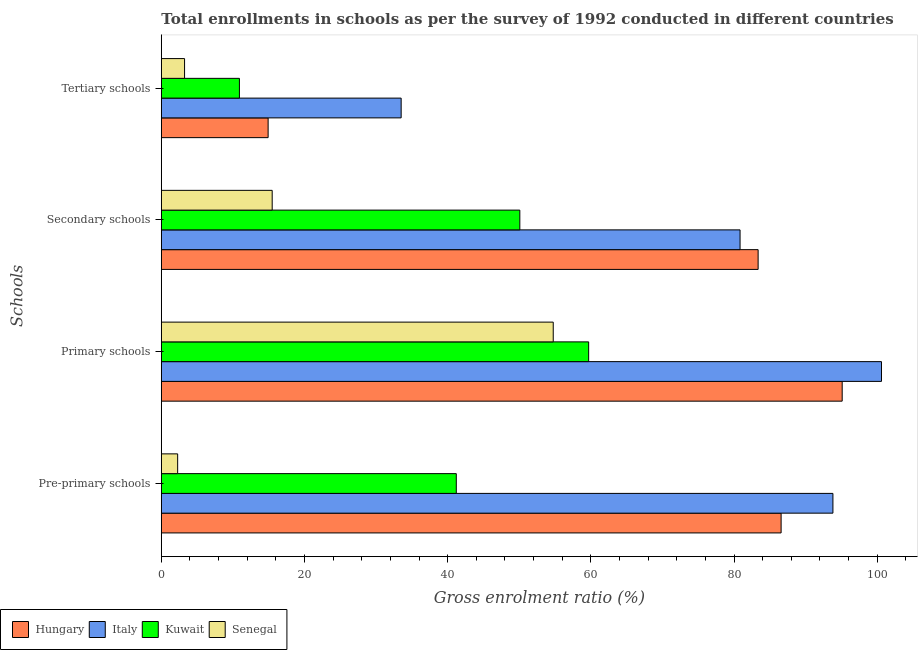Are the number of bars per tick equal to the number of legend labels?
Ensure brevity in your answer.  Yes. What is the label of the 4th group of bars from the top?
Make the answer very short. Pre-primary schools. What is the gross enrolment ratio in secondary schools in Senegal?
Give a very brief answer. 15.49. Across all countries, what is the maximum gross enrolment ratio in secondary schools?
Provide a succinct answer. 83.37. Across all countries, what is the minimum gross enrolment ratio in secondary schools?
Offer a terse response. 15.49. In which country was the gross enrolment ratio in pre-primary schools minimum?
Make the answer very short. Senegal. What is the total gross enrolment ratio in secondary schools in the graph?
Your response must be concise. 229.77. What is the difference between the gross enrolment ratio in tertiary schools in Kuwait and that in Hungary?
Offer a terse response. -4.01. What is the difference between the gross enrolment ratio in secondary schools in Senegal and the gross enrolment ratio in tertiary schools in Hungary?
Your answer should be compact. 0.57. What is the average gross enrolment ratio in primary schools per country?
Your answer should be compact. 77.54. What is the difference between the gross enrolment ratio in primary schools and gross enrolment ratio in secondary schools in Kuwait?
Give a very brief answer. 9.61. In how many countries, is the gross enrolment ratio in pre-primary schools greater than 4 %?
Ensure brevity in your answer.  3. What is the ratio of the gross enrolment ratio in primary schools in Senegal to that in Italy?
Your answer should be very brief. 0.54. Is the difference between the gross enrolment ratio in primary schools in Hungary and Kuwait greater than the difference between the gross enrolment ratio in pre-primary schools in Hungary and Kuwait?
Keep it short and to the point. No. What is the difference between the highest and the second highest gross enrolment ratio in secondary schools?
Offer a very short reply. 2.52. What is the difference between the highest and the lowest gross enrolment ratio in tertiary schools?
Keep it short and to the point. 30.25. Is the sum of the gross enrolment ratio in primary schools in Kuwait and Senegal greater than the maximum gross enrolment ratio in pre-primary schools across all countries?
Make the answer very short. Yes. What does the 4th bar from the top in Tertiary schools represents?
Your response must be concise. Hungary. What does the 4th bar from the bottom in Secondary schools represents?
Provide a succinct answer. Senegal. Is it the case that in every country, the sum of the gross enrolment ratio in pre-primary schools and gross enrolment ratio in primary schools is greater than the gross enrolment ratio in secondary schools?
Provide a short and direct response. Yes. How many bars are there?
Keep it short and to the point. 16. Are the values on the major ticks of X-axis written in scientific E-notation?
Your response must be concise. No. Does the graph contain any zero values?
Offer a terse response. No. Where does the legend appear in the graph?
Provide a short and direct response. Bottom left. How many legend labels are there?
Ensure brevity in your answer.  4. How are the legend labels stacked?
Your answer should be very brief. Horizontal. What is the title of the graph?
Offer a terse response. Total enrollments in schools as per the survey of 1992 conducted in different countries. What is the label or title of the X-axis?
Your answer should be compact. Gross enrolment ratio (%). What is the label or title of the Y-axis?
Provide a short and direct response. Schools. What is the Gross enrolment ratio (%) of Hungary in Pre-primary schools?
Keep it short and to the point. 86.58. What is the Gross enrolment ratio (%) in Italy in Pre-primary schools?
Keep it short and to the point. 93.81. What is the Gross enrolment ratio (%) in Kuwait in Pre-primary schools?
Give a very brief answer. 41.2. What is the Gross enrolment ratio (%) of Senegal in Pre-primary schools?
Provide a succinct answer. 2.28. What is the Gross enrolment ratio (%) in Hungary in Primary schools?
Give a very brief answer. 95.11. What is the Gross enrolment ratio (%) in Italy in Primary schools?
Provide a short and direct response. 100.6. What is the Gross enrolment ratio (%) in Kuwait in Primary schools?
Keep it short and to the point. 59.69. What is the Gross enrolment ratio (%) in Senegal in Primary schools?
Ensure brevity in your answer.  54.75. What is the Gross enrolment ratio (%) in Hungary in Secondary schools?
Your response must be concise. 83.37. What is the Gross enrolment ratio (%) of Italy in Secondary schools?
Ensure brevity in your answer.  80.84. What is the Gross enrolment ratio (%) of Kuwait in Secondary schools?
Your response must be concise. 50.08. What is the Gross enrolment ratio (%) of Senegal in Secondary schools?
Ensure brevity in your answer.  15.49. What is the Gross enrolment ratio (%) in Hungary in Tertiary schools?
Make the answer very short. 14.92. What is the Gross enrolment ratio (%) in Italy in Tertiary schools?
Provide a short and direct response. 33.5. What is the Gross enrolment ratio (%) in Kuwait in Tertiary schools?
Your answer should be very brief. 10.91. What is the Gross enrolment ratio (%) in Senegal in Tertiary schools?
Provide a short and direct response. 3.25. Across all Schools, what is the maximum Gross enrolment ratio (%) of Hungary?
Offer a terse response. 95.11. Across all Schools, what is the maximum Gross enrolment ratio (%) in Italy?
Give a very brief answer. 100.6. Across all Schools, what is the maximum Gross enrolment ratio (%) of Kuwait?
Keep it short and to the point. 59.69. Across all Schools, what is the maximum Gross enrolment ratio (%) in Senegal?
Make the answer very short. 54.75. Across all Schools, what is the minimum Gross enrolment ratio (%) of Hungary?
Offer a terse response. 14.92. Across all Schools, what is the minimum Gross enrolment ratio (%) of Italy?
Offer a terse response. 33.5. Across all Schools, what is the minimum Gross enrolment ratio (%) in Kuwait?
Make the answer very short. 10.91. Across all Schools, what is the minimum Gross enrolment ratio (%) in Senegal?
Your response must be concise. 2.28. What is the total Gross enrolment ratio (%) of Hungary in the graph?
Offer a terse response. 279.97. What is the total Gross enrolment ratio (%) of Italy in the graph?
Give a very brief answer. 308.76. What is the total Gross enrolment ratio (%) of Kuwait in the graph?
Provide a succinct answer. 161.89. What is the total Gross enrolment ratio (%) of Senegal in the graph?
Your response must be concise. 75.76. What is the difference between the Gross enrolment ratio (%) in Hungary in Pre-primary schools and that in Primary schools?
Ensure brevity in your answer.  -8.53. What is the difference between the Gross enrolment ratio (%) of Italy in Pre-primary schools and that in Primary schools?
Give a very brief answer. -6.78. What is the difference between the Gross enrolment ratio (%) in Kuwait in Pre-primary schools and that in Primary schools?
Offer a very short reply. -18.49. What is the difference between the Gross enrolment ratio (%) of Senegal in Pre-primary schools and that in Primary schools?
Your response must be concise. -52.46. What is the difference between the Gross enrolment ratio (%) of Hungary in Pre-primary schools and that in Secondary schools?
Offer a very short reply. 3.21. What is the difference between the Gross enrolment ratio (%) in Italy in Pre-primary schools and that in Secondary schools?
Make the answer very short. 12.97. What is the difference between the Gross enrolment ratio (%) in Kuwait in Pre-primary schools and that in Secondary schools?
Make the answer very short. -8.88. What is the difference between the Gross enrolment ratio (%) in Senegal in Pre-primary schools and that in Secondary schools?
Your response must be concise. -13.2. What is the difference between the Gross enrolment ratio (%) of Hungary in Pre-primary schools and that in Tertiary schools?
Your response must be concise. 71.66. What is the difference between the Gross enrolment ratio (%) in Italy in Pre-primary schools and that in Tertiary schools?
Your answer should be very brief. 60.31. What is the difference between the Gross enrolment ratio (%) of Kuwait in Pre-primary schools and that in Tertiary schools?
Your answer should be very brief. 30.29. What is the difference between the Gross enrolment ratio (%) in Senegal in Pre-primary schools and that in Tertiary schools?
Your answer should be compact. -0.97. What is the difference between the Gross enrolment ratio (%) in Hungary in Primary schools and that in Secondary schools?
Give a very brief answer. 11.74. What is the difference between the Gross enrolment ratio (%) in Italy in Primary schools and that in Secondary schools?
Offer a terse response. 19.75. What is the difference between the Gross enrolment ratio (%) of Kuwait in Primary schools and that in Secondary schools?
Offer a very short reply. 9.61. What is the difference between the Gross enrolment ratio (%) of Senegal in Primary schools and that in Secondary schools?
Keep it short and to the point. 39.26. What is the difference between the Gross enrolment ratio (%) of Hungary in Primary schools and that in Tertiary schools?
Provide a succinct answer. 80.19. What is the difference between the Gross enrolment ratio (%) of Italy in Primary schools and that in Tertiary schools?
Your response must be concise. 67.09. What is the difference between the Gross enrolment ratio (%) in Kuwait in Primary schools and that in Tertiary schools?
Ensure brevity in your answer.  48.78. What is the difference between the Gross enrolment ratio (%) of Senegal in Primary schools and that in Tertiary schools?
Your response must be concise. 51.5. What is the difference between the Gross enrolment ratio (%) in Hungary in Secondary schools and that in Tertiary schools?
Offer a very short reply. 68.45. What is the difference between the Gross enrolment ratio (%) of Italy in Secondary schools and that in Tertiary schools?
Your response must be concise. 47.34. What is the difference between the Gross enrolment ratio (%) of Kuwait in Secondary schools and that in Tertiary schools?
Ensure brevity in your answer.  39.17. What is the difference between the Gross enrolment ratio (%) of Senegal in Secondary schools and that in Tertiary schools?
Keep it short and to the point. 12.24. What is the difference between the Gross enrolment ratio (%) of Hungary in Pre-primary schools and the Gross enrolment ratio (%) of Italy in Primary schools?
Give a very brief answer. -14.02. What is the difference between the Gross enrolment ratio (%) of Hungary in Pre-primary schools and the Gross enrolment ratio (%) of Kuwait in Primary schools?
Your answer should be very brief. 26.88. What is the difference between the Gross enrolment ratio (%) in Hungary in Pre-primary schools and the Gross enrolment ratio (%) in Senegal in Primary schools?
Your response must be concise. 31.83. What is the difference between the Gross enrolment ratio (%) in Italy in Pre-primary schools and the Gross enrolment ratio (%) in Kuwait in Primary schools?
Ensure brevity in your answer.  34.12. What is the difference between the Gross enrolment ratio (%) in Italy in Pre-primary schools and the Gross enrolment ratio (%) in Senegal in Primary schools?
Ensure brevity in your answer.  39.07. What is the difference between the Gross enrolment ratio (%) in Kuwait in Pre-primary schools and the Gross enrolment ratio (%) in Senegal in Primary schools?
Your answer should be compact. -13.54. What is the difference between the Gross enrolment ratio (%) of Hungary in Pre-primary schools and the Gross enrolment ratio (%) of Italy in Secondary schools?
Your answer should be very brief. 5.73. What is the difference between the Gross enrolment ratio (%) in Hungary in Pre-primary schools and the Gross enrolment ratio (%) in Kuwait in Secondary schools?
Make the answer very short. 36.5. What is the difference between the Gross enrolment ratio (%) in Hungary in Pre-primary schools and the Gross enrolment ratio (%) in Senegal in Secondary schools?
Provide a short and direct response. 71.09. What is the difference between the Gross enrolment ratio (%) in Italy in Pre-primary schools and the Gross enrolment ratio (%) in Kuwait in Secondary schools?
Make the answer very short. 43.73. What is the difference between the Gross enrolment ratio (%) of Italy in Pre-primary schools and the Gross enrolment ratio (%) of Senegal in Secondary schools?
Give a very brief answer. 78.33. What is the difference between the Gross enrolment ratio (%) of Kuwait in Pre-primary schools and the Gross enrolment ratio (%) of Senegal in Secondary schools?
Your answer should be compact. 25.72. What is the difference between the Gross enrolment ratio (%) in Hungary in Pre-primary schools and the Gross enrolment ratio (%) in Italy in Tertiary schools?
Your answer should be very brief. 53.07. What is the difference between the Gross enrolment ratio (%) of Hungary in Pre-primary schools and the Gross enrolment ratio (%) of Kuwait in Tertiary schools?
Give a very brief answer. 75.67. What is the difference between the Gross enrolment ratio (%) in Hungary in Pre-primary schools and the Gross enrolment ratio (%) in Senegal in Tertiary schools?
Keep it short and to the point. 83.33. What is the difference between the Gross enrolment ratio (%) in Italy in Pre-primary schools and the Gross enrolment ratio (%) in Kuwait in Tertiary schools?
Offer a very short reply. 82.9. What is the difference between the Gross enrolment ratio (%) of Italy in Pre-primary schools and the Gross enrolment ratio (%) of Senegal in Tertiary schools?
Offer a terse response. 90.57. What is the difference between the Gross enrolment ratio (%) in Kuwait in Pre-primary schools and the Gross enrolment ratio (%) in Senegal in Tertiary schools?
Offer a terse response. 37.96. What is the difference between the Gross enrolment ratio (%) of Hungary in Primary schools and the Gross enrolment ratio (%) of Italy in Secondary schools?
Keep it short and to the point. 14.26. What is the difference between the Gross enrolment ratio (%) of Hungary in Primary schools and the Gross enrolment ratio (%) of Kuwait in Secondary schools?
Your answer should be compact. 45.03. What is the difference between the Gross enrolment ratio (%) of Hungary in Primary schools and the Gross enrolment ratio (%) of Senegal in Secondary schools?
Keep it short and to the point. 79.62. What is the difference between the Gross enrolment ratio (%) in Italy in Primary schools and the Gross enrolment ratio (%) in Kuwait in Secondary schools?
Provide a succinct answer. 50.52. What is the difference between the Gross enrolment ratio (%) in Italy in Primary schools and the Gross enrolment ratio (%) in Senegal in Secondary schools?
Make the answer very short. 85.11. What is the difference between the Gross enrolment ratio (%) of Kuwait in Primary schools and the Gross enrolment ratio (%) of Senegal in Secondary schools?
Keep it short and to the point. 44.21. What is the difference between the Gross enrolment ratio (%) of Hungary in Primary schools and the Gross enrolment ratio (%) of Italy in Tertiary schools?
Give a very brief answer. 61.6. What is the difference between the Gross enrolment ratio (%) in Hungary in Primary schools and the Gross enrolment ratio (%) in Kuwait in Tertiary schools?
Give a very brief answer. 84.2. What is the difference between the Gross enrolment ratio (%) in Hungary in Primary schools and the Gross enrolment ratio (%) in Senegal in Tertiary schools?
Make the answer very short. 91.86. What is the difference between the Gross enrolment ratio (%) in Italy in Primary schools and the Gross enrolment ratio (%) in Kuwait in Tertiary schools?
Provide a succinct answer. 89.69. What is the difference between the Gross enrolment ratio (%) of Italy in Primary schools and the Gross enrolment ratio (%) of Senegal in Tertiary schools?
Provide a succinct answer. 97.35. What is the difference between the Gross enrolment ratio (%) in Kuwait in Primary schools and the Gross enrolment ratio (%) in Senegal in Tertiary schools?
Give a very brief answer. 56.45. What is the difference between the Gross enrolment ratio (%) of Hungary in Secondary schools and the Gross enrolment ratio (%) of Italy in Tertiary schools?
Offer a terse response. 49.86. What is the difference between the Gross enrolment ratio (%) in Hungary in Secondary schools and the Gross enrolment ratio (%) in Kuwait in Tertiary schools?
Your response must be concise. 72.46. What is the difference between the Gross enrolment ratio (%) in Hungary in Secondary schools and the Gross enrolment ratio (%) in Senegal in Tertiary schools?
Offer a very short reply. 80.12. What is the difference between the Gross enrolment ratio (%) of Italy in Secondary schools and the Gross enrolment ratio (%) of Kuwait in Tertiary schools?
Ensure brevity in your answer.  69.93. What is the difference between the Gross enrolment ratio (%) in Italy in Secondary schools and the Gross enrolment ratio (%) in Senegal in Tertiary schools?
Offer a very short reply. 77.6. What is the difference between the Gross enrolment ratio (%) of Kuwait in Secondary schools and the Gross enrolment ratio (%) of Senegal in Tertiary schools?
Ensure brevity in your answer.  46.83. What is the average Gross enrolment ratio (%) in Hungary per Schools?
Your response must be concise. 69.99. What is the average Gross enrolment ratio (%) of Italy per Schools?
Make the answer very short. 77.19. What is the average Gross enrolment ratio (%) in Kuwait per Schools?
Make the answer very short. 40.47. What is the average Gross enrolment ratio (%) in Senegal per Schools?
Make the answer very short. 18.94. What is the difference between the Gross enrolment ratio (%) of Hungary and Gross enrolment ratio (%) of Italy in Pre-primary schools?
Provide a succinct answer. -7.24. What is the difference between the Gross enrolment ratio (%) of Hungary and Gross enrolment ratio (%) of Kuwait in Pre-primary schools?
Keep it short and to the point. 45.37. What is the difference between the Gross enrolment ratio (%) in Hungary and Gross enrolment ratio (%) in Senegal in Pre-primary schools?
Offer a very short reply. 84.29. What is the difference between the Gross enrolment ratio (%) of Italy and Gross enrolment ratio (%) of Kuwait in Pre-primary schools?
Give a very brief answer. 52.61. What is the difference between the Gross enrolment ratio (%) of Italy and Gross enrolment ratio (%) of Senegal in Pre-primary schools?
Ensure brevity in your answer.  91.53. What is the difference between the Gross enrolment ratio (%) of Kuwait and Gross enrolment ratio (%) of Senegal in Pre-primary schools?
Offer a terse response. 38.92. What is the difference between the Gross enrolment ratio (%) in Hungary and Gross enrolment ratio (%) in Italy in Primary schools?
Offer a terse response. -5.49. What is the difference between the Gross enrolment ratio (%) of Hungary and Gross enrolment ratio (%) of Kuwait in Primary schools?
Provide a succinct answer. 35.41. What is the difference between the Gross enrolment ratio (%) in Hungary and Gross enrolment ratio (%) in Senegal in Primary schools?
Give a very brief answer. 40.36. What is the difference between the Gross enrolment ratio (%) in Italy and Gross enrolment ratio (%) in Kuwait in Primary schools?
Make the answer very short. 40.9. What is the difference between the Gross enrolment ratio (%) in Italy and Gross enrolment ratio (%) in Senegal in Primary schools?
Make the answer very short. 45.85. What is the difference between the Gross enrolment ratio (%) of Kuwait and Gross enrolment ratio (%) of Senegal in Primary schools?
Your response must be concise. 4.95. What is the difference between the Gross enrolment ratio (%) of Hungary and Gross enrolment ratio (%) of Italy in Secondary schools?
Make the answer very short. 2.52. What is the difference between the Gross enrolment ratio (%) of Hungary and Gross enrolment ratio (%) of Kuwait in Secondary schools?
Provide a short and direct response. 33.29. What is the difference between the Gross enrolment ratio (%) in Hungary and Gross enrolment ratio (%) in Senegal in Secondary schools?
Provide a succinct answer. 67.88. What is the difference between the Gross enrolment ratio (%) of Italy and Gross enrolment ratio (%) of Kuwait in Secondary schools?
Make the answer very short. 30.76. What is the difference between the Gross enrolment ratio (%) in Italy and Gross enrolment ratio (%) in Senegal in Secondary schools?
Offer a very short reply. 65.36. What is the difference between the Gross enrolment ratio (%) of Kuwait and Gross enrolment ratio (%) of Senegal in Secondary schools?
Provide a succinct answer. 34.59. What is the difference between the Gross enrolment ratio (%) in Hungary and Gross enrolment ratio (%) in Italy in Tertiary schools?
Provide a succinct answer. -18.58. What is the difference between the Gross enrolment ratio (%) in Hungary and Gross enrolment ratio (%) in Kuwait in Tertiary schools?
Make the answer very short. 4.01. What is the difference between the Gross enrolment ratio (%) of Hungary and Gross enrolment ratio (%) of Senegal in Tertiary schools?
Give a very brief answer. 11.67. What is the difference between the Gross enrolment ratio (%) in Italy and Gross enrolment ratio (%) in Kuwait in Tertiary schools?
Make the answer very short. 22.59. What is the difference between the Gross enrolment ratio (%) of Italy and Gross enrolment ratio (%) of Senegal in Tertiary schools?
Keep it short and to the point. 30.25. What is the difference between the Gross enrolment ratio (%) of Kuwait and Gross enrolment ratio (%) of Senegal in Tertiary schools?
Your response must be concise. 7.66. What is the ratio of the Gross enrolment ratio (%) in Hungary in Pre-primary schools to that in Primary schools?
Offer a terse response. 0.91. What is the ratio of the Gross enrolment ratio (%) in Italy in Pre-primary schools to that in Primary schools?
Offer a terse response. 0.93. What is the ratio of the Gross enrolment ratio (%) in Kuwait in Pre-primary schools to that in Primary schools?
Keep it short and to the point. 0.69. What is the ratio of the Gross enrolment ratio (%) in Senegal in Pre-primary schools to that in Primary schools?
Your answer should be very brief. 0.04. What is the ratio of the Gross enrolment ratio (%) of Hungary in Pre-primary schools to that in Secondary schools?
Offer a very short reply. 1.04. What is the ratio of the Gross enrolment ratio (%) in Italy in Pre-primary schools to that in Secondary schools?
Give a very brief answer. 1.16. What is the ratio of the Gross enrolment ratio (%) of Kuwait in Pre-primary schools to that in Secondary schools?
Provide a succinct answer. 0.82. What is the ratio of the Gross enrolment ratio (%) of Senegal in Pre-primary schools to that in Secondary schools?
Keep it short and to the point. 0.15. What is the ratio of the Gross enrolment ratio (%) of Hungary in Pre-primary schools to that in Tertiary schools?
Ensure brevity in your answer.  5.8. What is the ratio of the Gross enrolment ratio (%) in Italy in Pre-primary schools to that in Tertiary schools?
Provide a short and direct response. 2.8. What is the ratio of the Gross enrolment ratio (%) in Kuwait in Pre-primary schools to that in Tertiary schools?
Offer a very short reply. 3.78. What is the ratio of the Gross enrolment ratio (%) in Senegal in Pre-primary schools to that in Tertiary schools?
Ensure brevity in your answer.  0.7. What is the ratio of the Gross enrolment ratio (%) of Hungary in Primary schools to that in Secondary schools?
Make the answer very short. 1.14. What is the ratio of the Gross enrolment ratio (%) in Italy in Primary schools to that in Secondary schools?
Offer a very short reply. 1.24. What is the ratio of the Gross enrolment ratio (%) of Kuwait in Primary schools to that in Secondary schools?
Offer a terse response. 1.19. What is the ratio of the Gross enrolment ratio (%) of Senegal in Primary schools to that in Secondary schools?
Provide a succinct answer. 3.54. What is the ratio of the Gross enrolment ratio (%) of Hungary in Primary schools to that in Tertiary schools?
Ensure brevity in your answer.  6.37. What is the ratio of the Gross enrolment ratio (%) of Italy in Primary schools to that in Tertiary schools?
Provide a short and direct response. 3. What is the ratio of the Gross enrolment ratio (%) of Kuwait in Primary schools to that in Tertiary schools?
Offer a terse response. 5.47. What is the ratio of the Gross enrolment ratio (%) of Senegal in Primary schools to that in Tertiary schools?
Your answer should be compact. 16.86. What is the ratio of the Gross enrolment ratio (%) of Hungary in Secondary schools to that in Tertiary schools?
Your response must be concise. 5.59. What is the ratio of the Gross enrolment ratio (%) in Italy in Secondary schools to that in Tertiary schools?
Provide a short and direct response. 2.41. What is the ratio of the Gross enrolment ratio (%) of Kuwait in Secondary schools to that in Tertiary schools?
Keep it short and to the point. 4.59. What is the ratio of the Gross enrolment ratio (%) in Senegal in Secondary schools to that in Tertiary schools?
Your response must be concise. 4.77. What is the difference between the highest and the second highest Gross enrolment ratio (%) in Hungary?
Keep it short and to the point. 8.53. What is the difference between the highest and the second highest Gross enrolment ratio (%) in Italy?
Provide a succinct answer. 6.78. What is the difference between the highest and the second highest Gross enrolment ratio (%) of Kuwait?
Give a very brief answer. 9.61. What is the difference between the highest and the second highest Gross enrolment ratio (%) of Senegal?
Provide a succinct answer. 39.26. What is the difference between the highest and the lowest Gross enrolment ratio (%) in Hungary?
Your answer should be very brief. 80.19. What is the difference between the highest and the lowest Gross enrolment ratio (%) of Italy?
Keep it short and to the point. 67.09. What is the difference between the highest and the lowest Gross enrolment ratio (%) of Kuwait?
Ensure brevity in your answer.  48.78. What is the difference between the highest and the lowest Gross enrolment ratio (%) of Senegal?
Your answer should be compact. 52.46. 